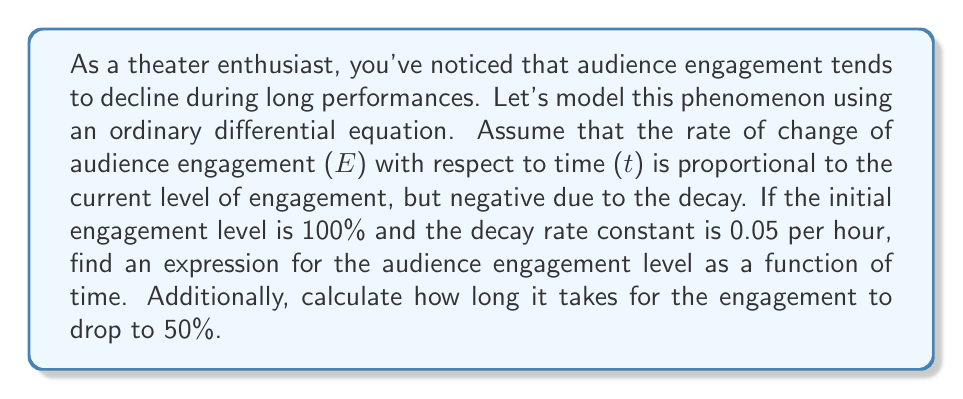Solve this math problem. Let's approach this step-by-step:

1) First, we need to set up our differential equation. Given that the rate of change of engagement is proportional to the current engagement level, we can write:

   $$\frac{dE}{dt} = -kE$$

   where $k$ is the decay rate constant, given as 0.05 per hour.

2) This is a separable differential equation. We can solve it as follows:

   $$\frac{dE}{E} = -k dt$$

3) Integrating both sides:

   $$\int \frac{dE}{E} = -k \int dt$$

   $$\ln|E| = -kt + C$$

4) Solving for E:

   $$E = e^{-kt + C} = Ae^{-kt}$$

   where $A = e^C$ is a constant we'll determine from the initial condition.

5) We're given that the initial engagement is 100%, so $E(0) = 100$. Let's use this:

   $$100 = Ae^{-k(0)} = A$$

6) Therefore, our solution is:

   $$E(t) = 100e^{-0.05t}$$

7) To find when the engagement drops to 50%, we solve:

   $$50 = 100e^{-0.05t}$$

   $$0.5 = e^{-0.05t}$$

   $$\ln(0.5) = -0.05t$$

   $$t = \frac{-\ln(0.5)}{0.05} \approx 13.86$$

Thus, it takes approximately 13.86 hours for the engagement to drop to 50%.
Answer: The audience engagement level as a function of time is given by $E(t) = 100e^{-0.05t}$, where $t$ is in hours. The time it takes for the engagement to drop to 50% is approximately 13.86 hours. 